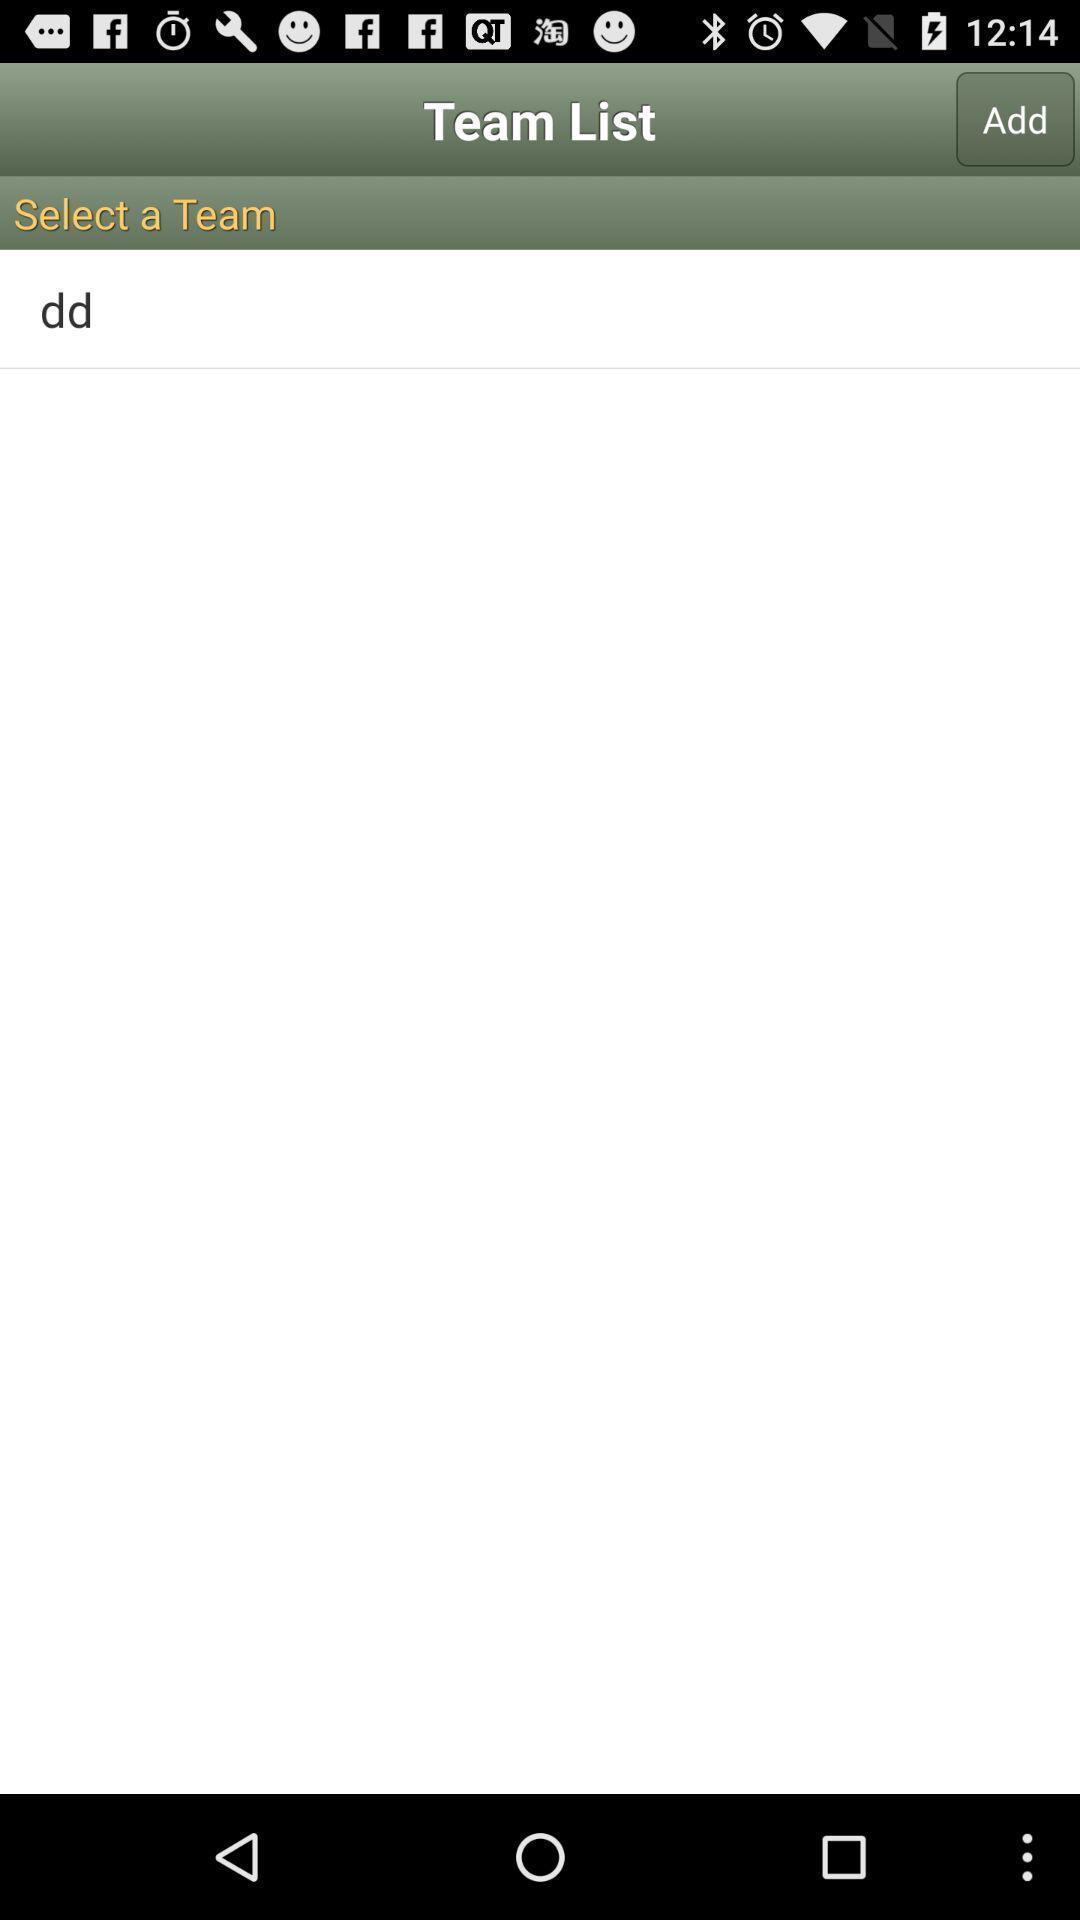Tell me what you see in this picture. Screen showing team list with add option. 